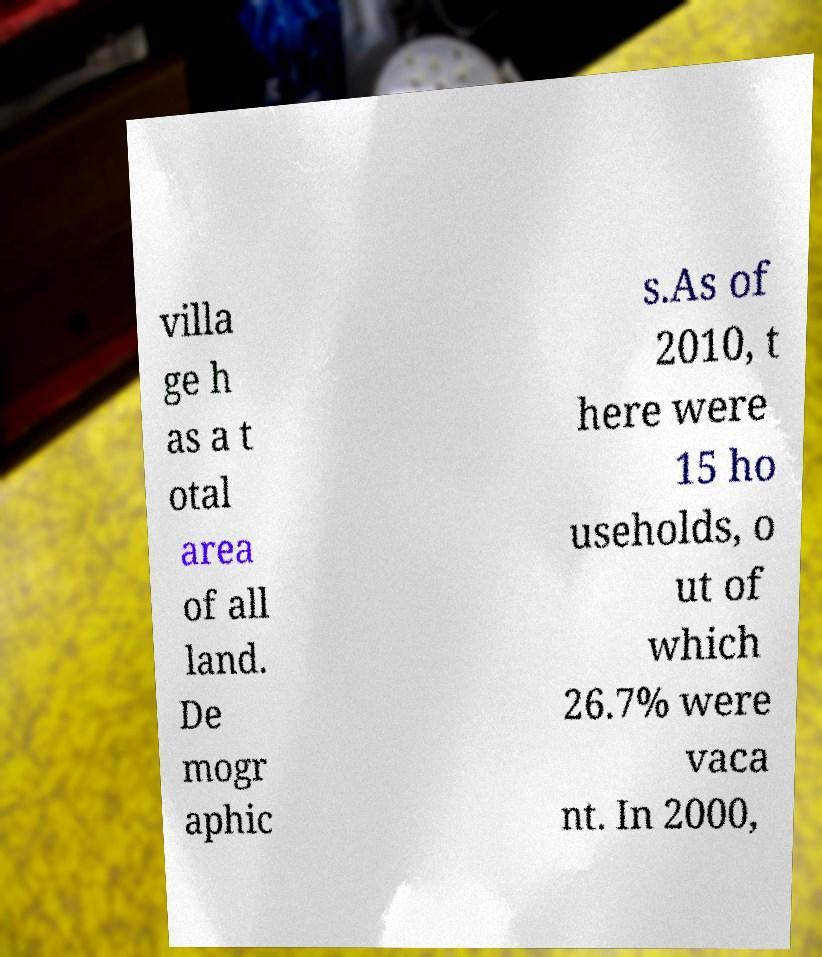Can you accurately transcribe the text from the provided image for me? villa ge h as a t otal area of all land. De mogr aphic s.As of 2010, t here were 15 ho useholds, o ut of which 26.7% were vaca nt. In 2000, 